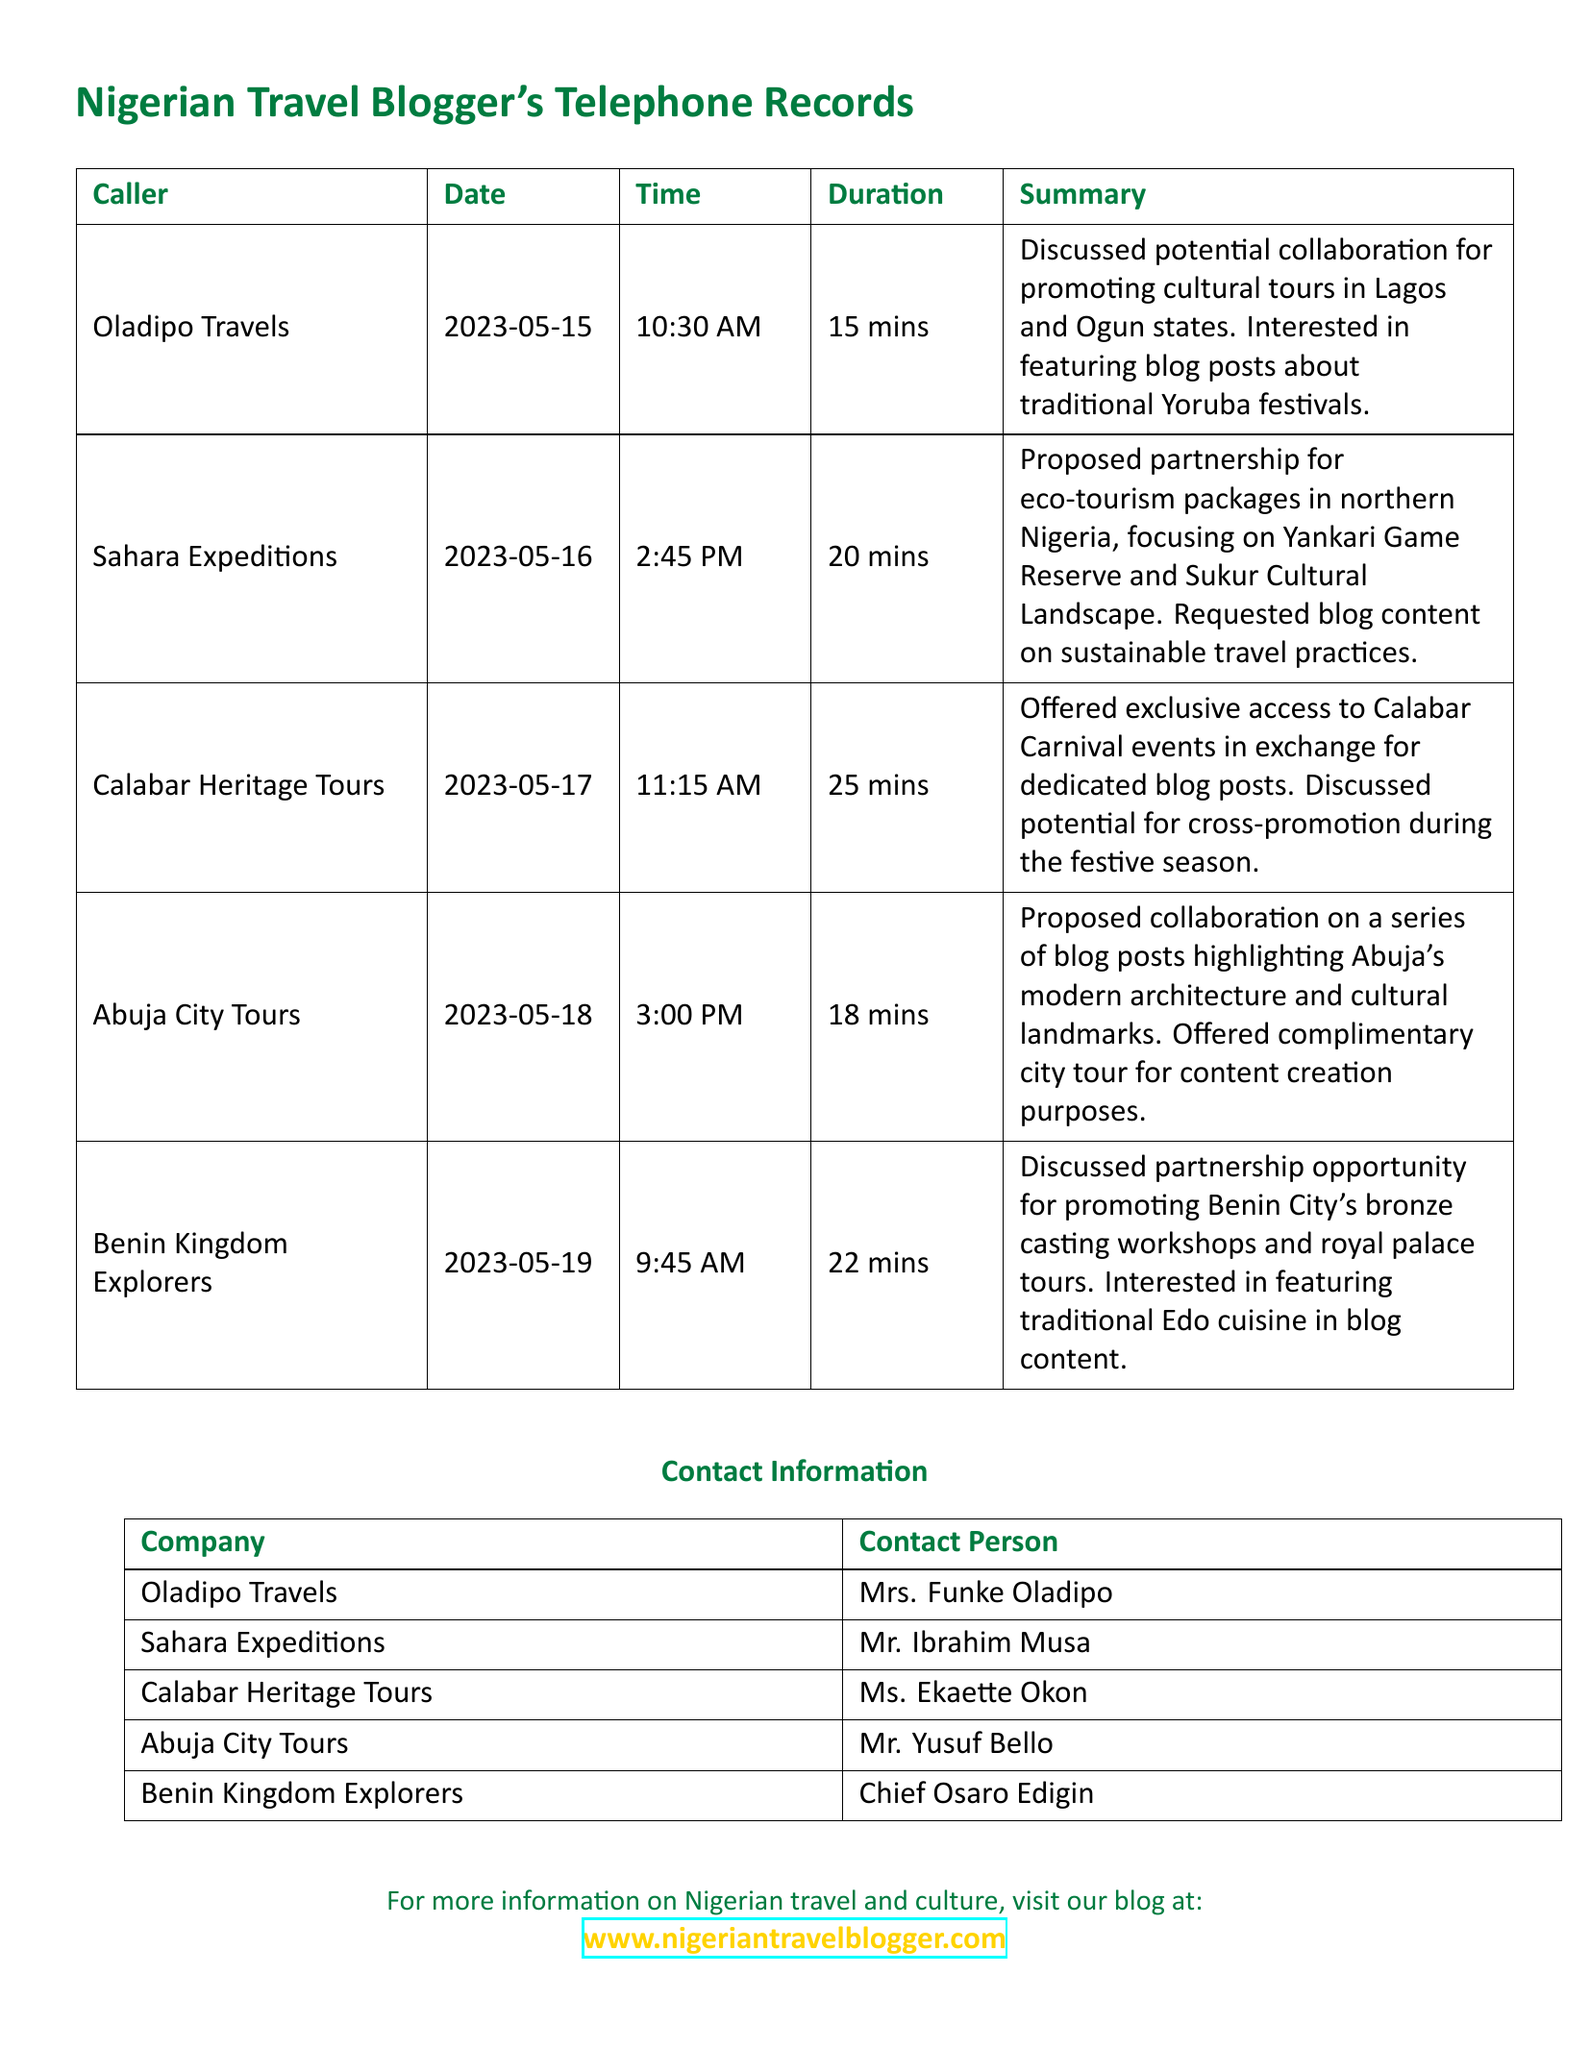What is the first call date? The first call date is the earliest date listed in the document, which is May 15, 2023.
Answer: 2023-05-15 Who called on May 16, 2023? The call made on May 16, 2023, was from Sahara Expeditions, as noted in the telephone records.
Answer: Sahara Expeditions How long was the call with Abuja City Tours? The duration of the call with Abuja City Tours, as recorded, is 18 minutes.
Answer: 18 mins What opportunity was discussed with Benin Kingdom Explorers? The partnership opportunity discussed includes promoting Benin City's bronze casting workshops and royal palace tours.
Answer: Promoting bronze casting workshops Which company offered exclusive access to a carnival event? Calabar Heritage Tours offered exclusive access to Calabar Carnival events in exchange for dedicated blog posts.
Answer: Calabar Heritage Tours What was proposed by Sahara Expeditions? Sahara Expeditions proposed a partnership for eco-tourism packages in northern Nigeria.
Answer: Eco-tourism packages Who is the contact person for Oladipo Travels? The contact person listed for Oladipo Travels is Mrs. Funke Oladipo.
Answer: Mrs. Funke Oladipo Which tour operator is interested in featuring blog content on sustainable travel practices? Sahara Expeditions is interested in featuring blog content on sustainable travel practices.
Answer: Sahara Expeditions 